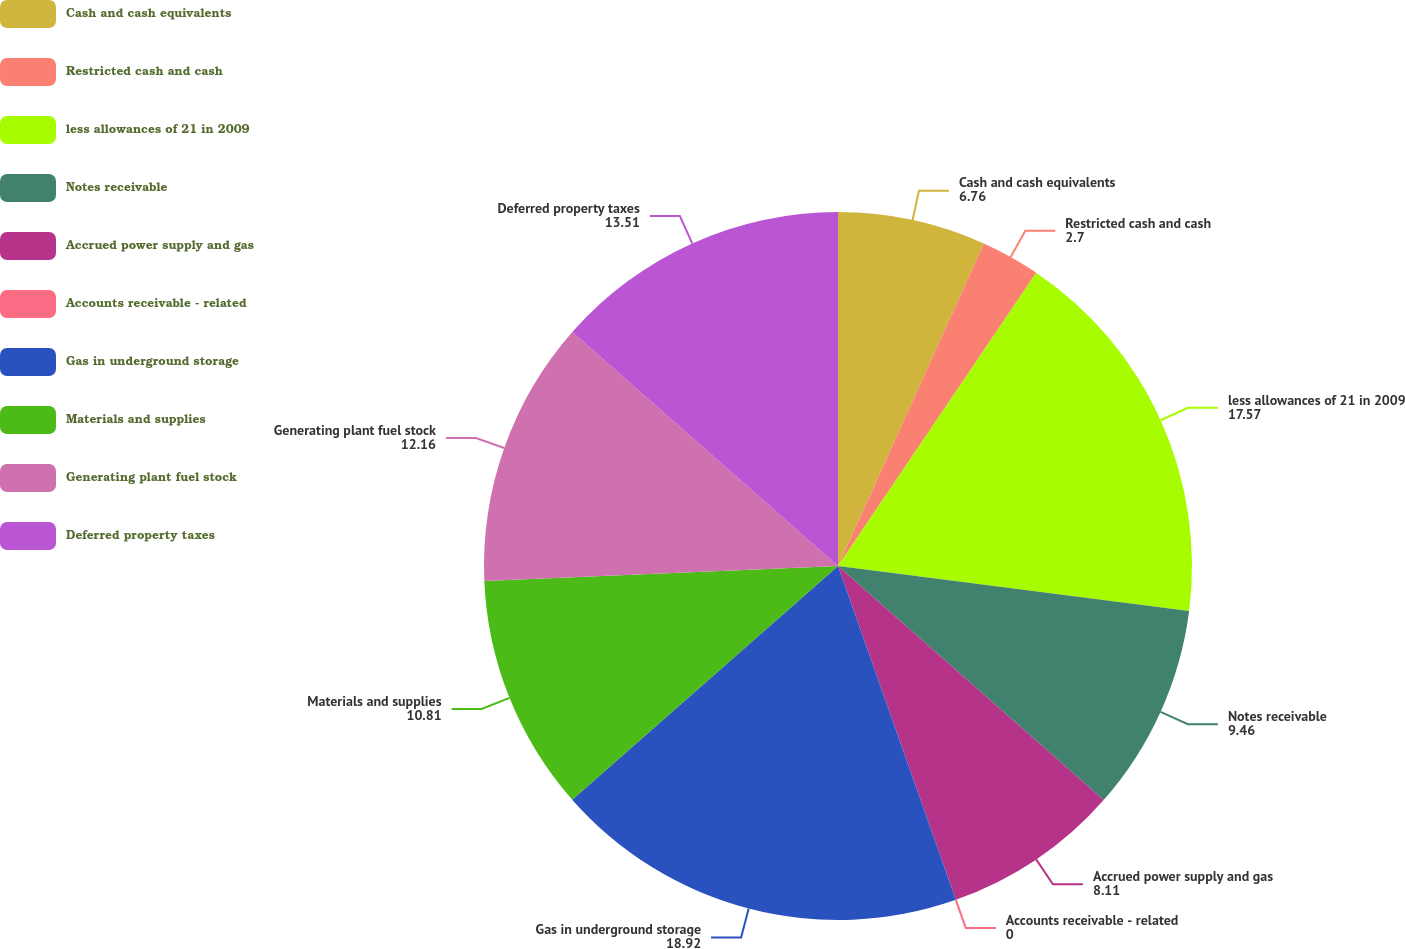Convert chart to OTSL. <chart><loc_0><loc_0><loc_500><loc_500><pie_chart><fcel>Cash and cash equivalents<fcel>Restricted cash and cash<fcel>less allowances of 21 in 2009<fcel>Notes receivable<fcel>Accrued power supply and gas<fcel>Accounts receivable - related<fcel>Gas in underground storage<fcel>Materials and supplies<fcel>Generating plant fuel stock<fcel>Deferred property taxes<nl><fcel>6.76%<fcel>2.7%<fcel>17.57%<fcel>9.46%<fcel>8.11%<fcel>0.0%<fcel>18.92%<fcel>10.81%<fcel>12.16%<fcel>13.51%<nl></chart> 